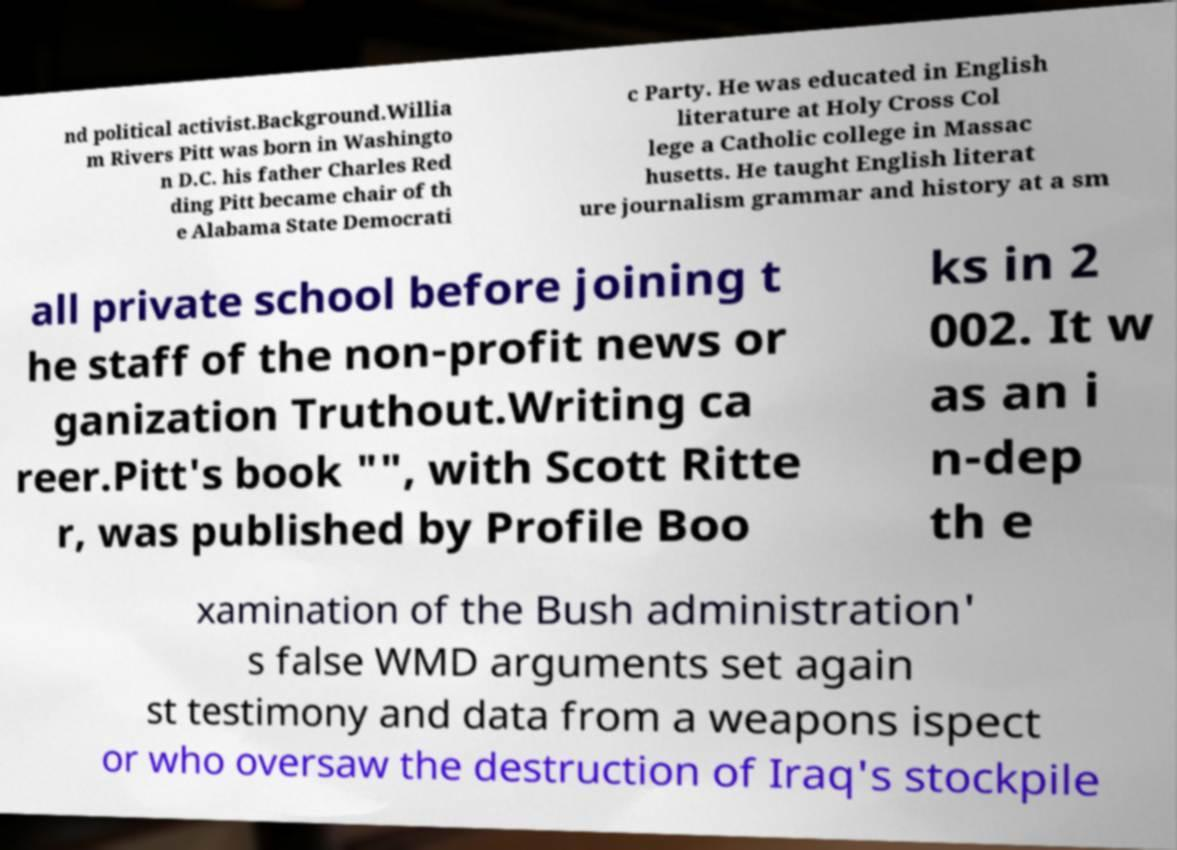Please read and relay the text visible in this image. What does it say? nd political activist.Background.Willia m Rivers Pitt was born in Washingto n D.C. his father Charles Red ding Pitt became chair of th e Alabama State Democrati c Party. He was educated in English literature at Holy Cross Col lege a Catholic college in Massac husetts. He taught English literat ure journalism grammar and history at a sm all private school before joining t he staff of the non-profit news or ganization Truthout.Writing ca reer.Pitt's book "", with Scott Ritte r, was published by Profile Boo ks in 2 002. It w as an i n-dep th e xamination of the Bush administration' s false WMD arguments set again st testimony and data from a weapons ispect or who oversaw the destruction of Iraq's stockpile 